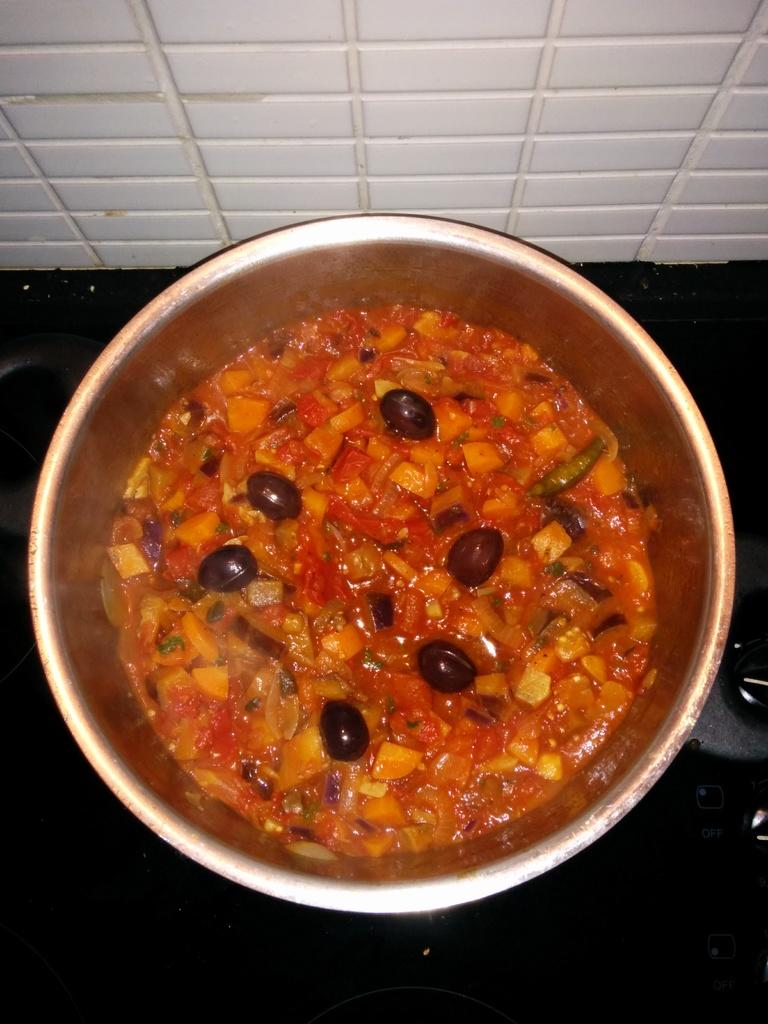What is the main subject of the image? There is a food item in the image. How is the food item presented in the image? The food item is in a bowl. What type of exchange is taking place between the food item and the pan in the image? There is no pan present in the image, and the food item is not involved in any exchange. 